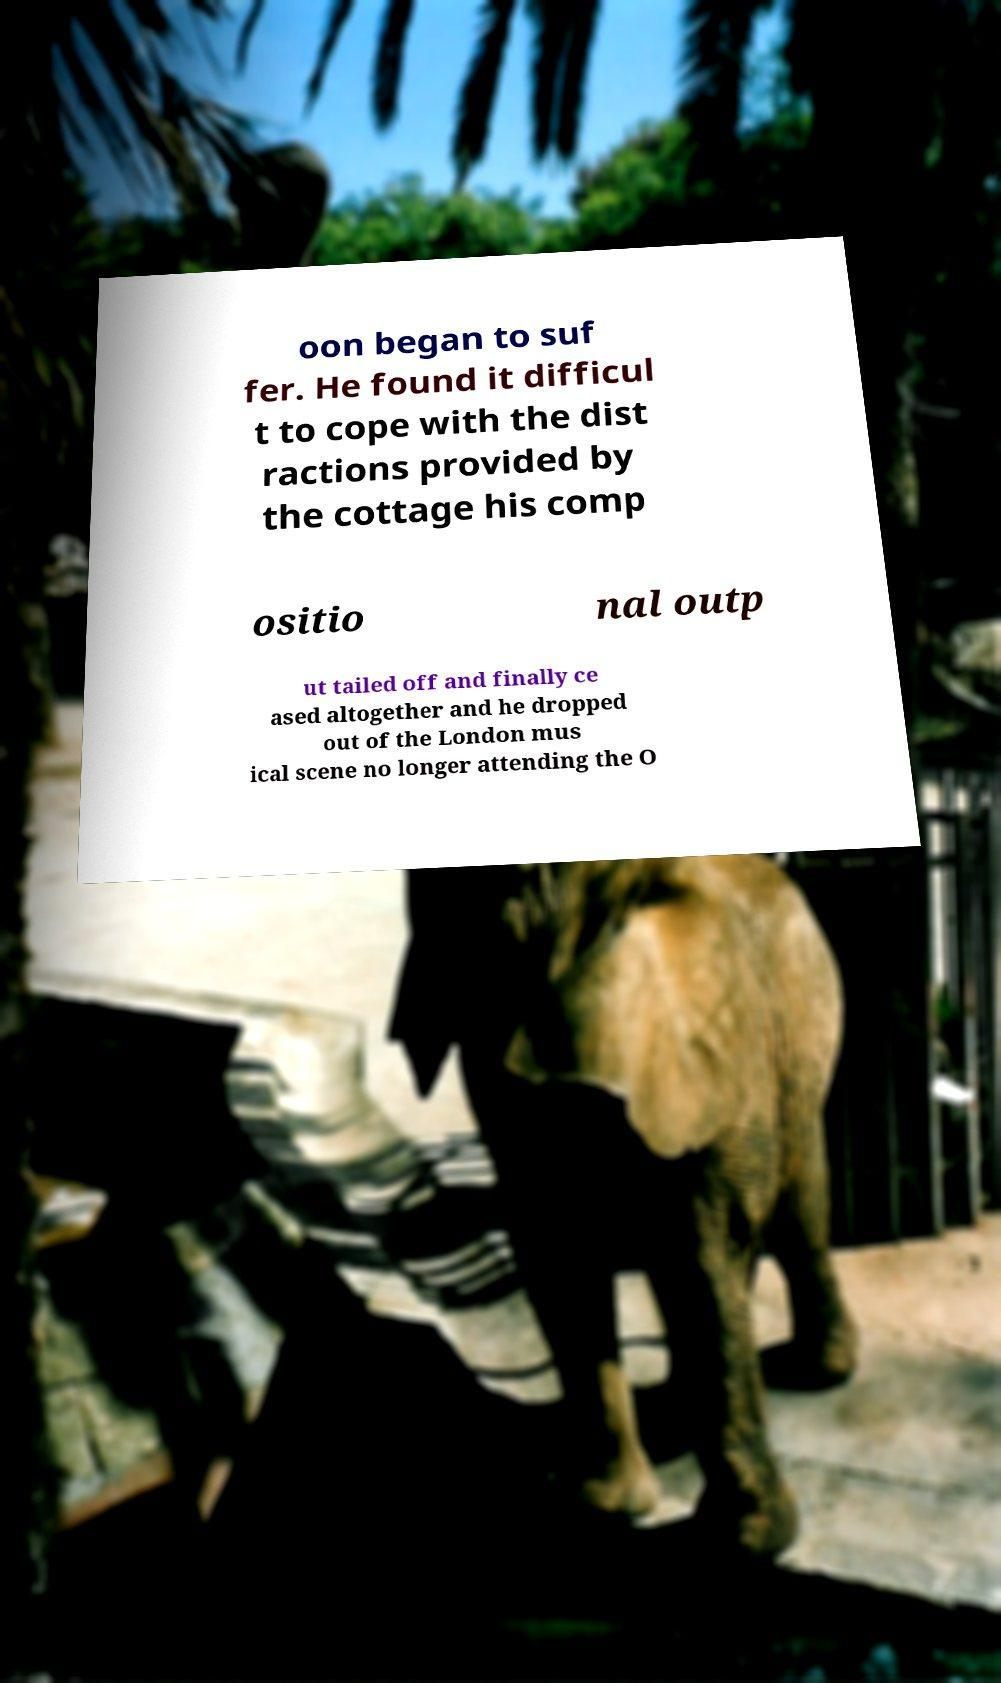I need the written content from this picture converted into text. Can you do that? oon began to suf fer. He found it difficul t to cope with the dist ractions provided by the cottage his comp ositio nal outp ut tailed off and finally ce ased altogether and he dropped out of the London mus ical scene no longer attending the O 